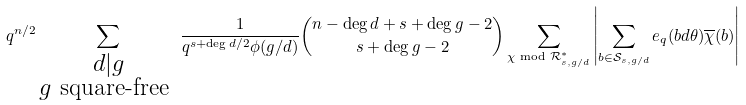<formula> <loc_0><loc_0><loc_500><loc_500>q ^ { n / 2 } \sum _ { \substack { d | g \\ g \text { square-free } } } \frac { 1 } { q ^ { s + \deg d / 2 } \phi ( g / d ) } { { n - \deg d + s + \deg g - 2 } \choose { s + \deg g - 2 } } \sum _ { \chi \text { mod } \mathcal { R } ^ { * } _ { s , g / d } } \left | \sum _ { b \in \mathcal { S } _ { s , g / d } } e _ { q } ( b d \theta ) \overline { \chi } ( b ) \right |</formula> 